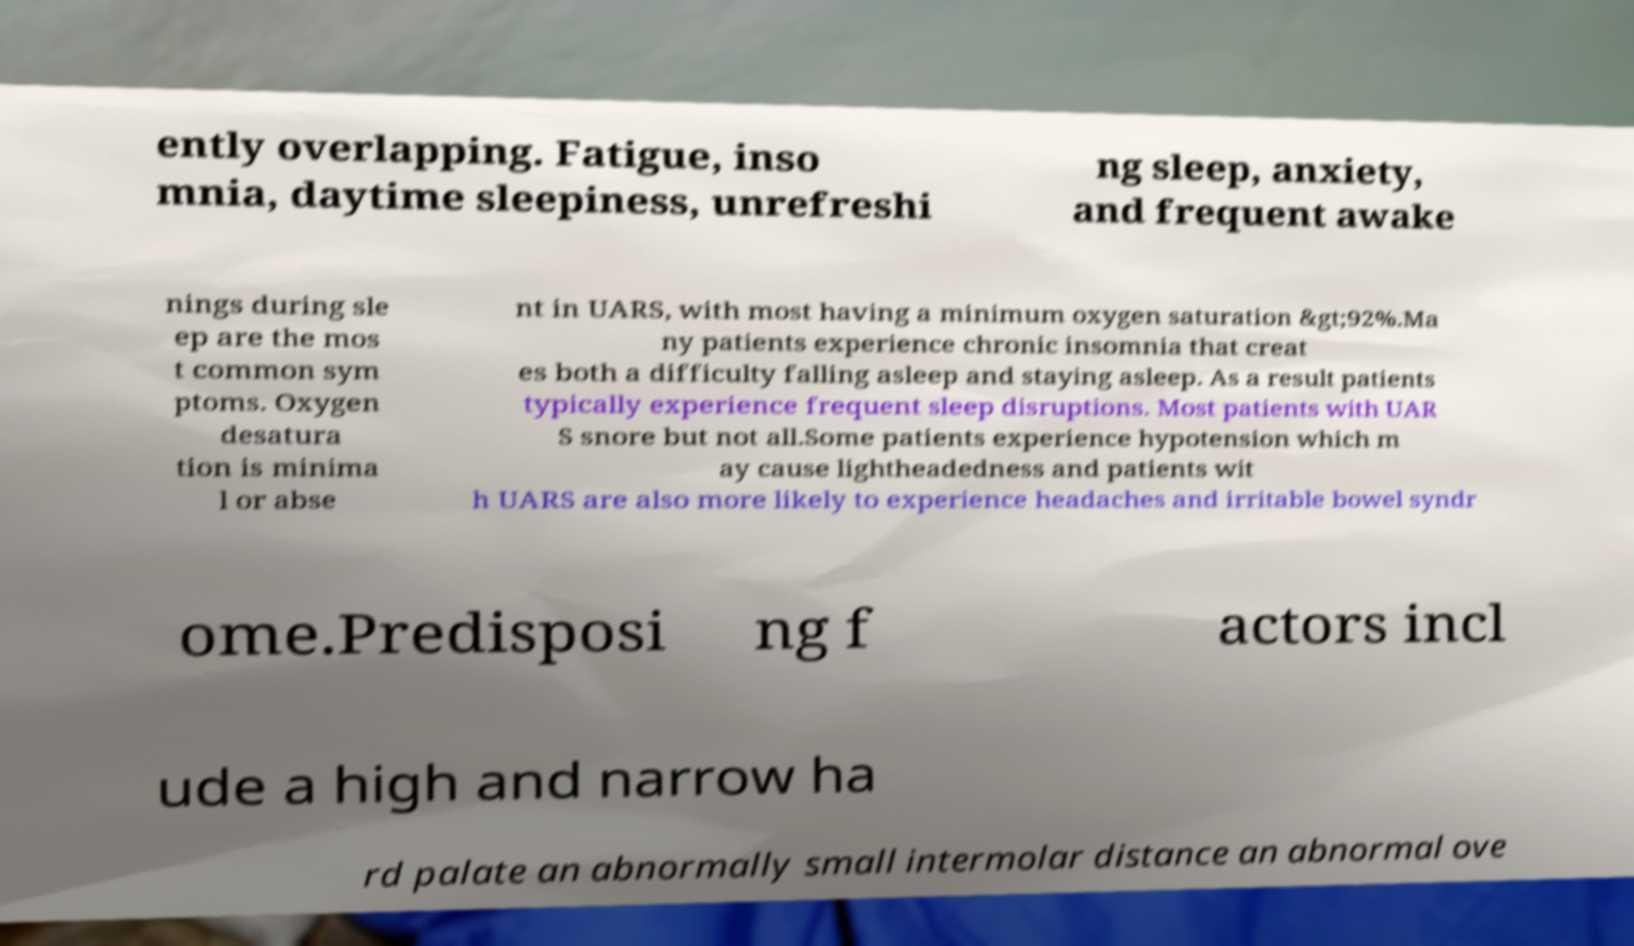For documentation purposes, I need the text within this image transcribed. Could you provide that? ently overlapping. Fatigue, inso mnia, daytime sleepiness, unrefreshi ng sleep, anxiety, and frequent awake nings during sle ep are the mos t common sym ptoms. Oxygen desatura tion is minima l or abse nt in UARS, with most having a minimum oxygen saturation &gt;92%.Ma ny patients experience chronic insomnia that creat es both a difficulty falling asleep and staying asleep. As a result patients typically experience frequent sleep disruptions. Most patients with UAR S snore but not all.Some patients experience hypotension which m ay cause lightheadedness and patients wit h UARS are also more likely to experience headaches and irritable bowel syndr ome.Predisposi ng f actors incl ude a high and narrow ha rd palate an abnormally small intermolar distance an abnormal ove 